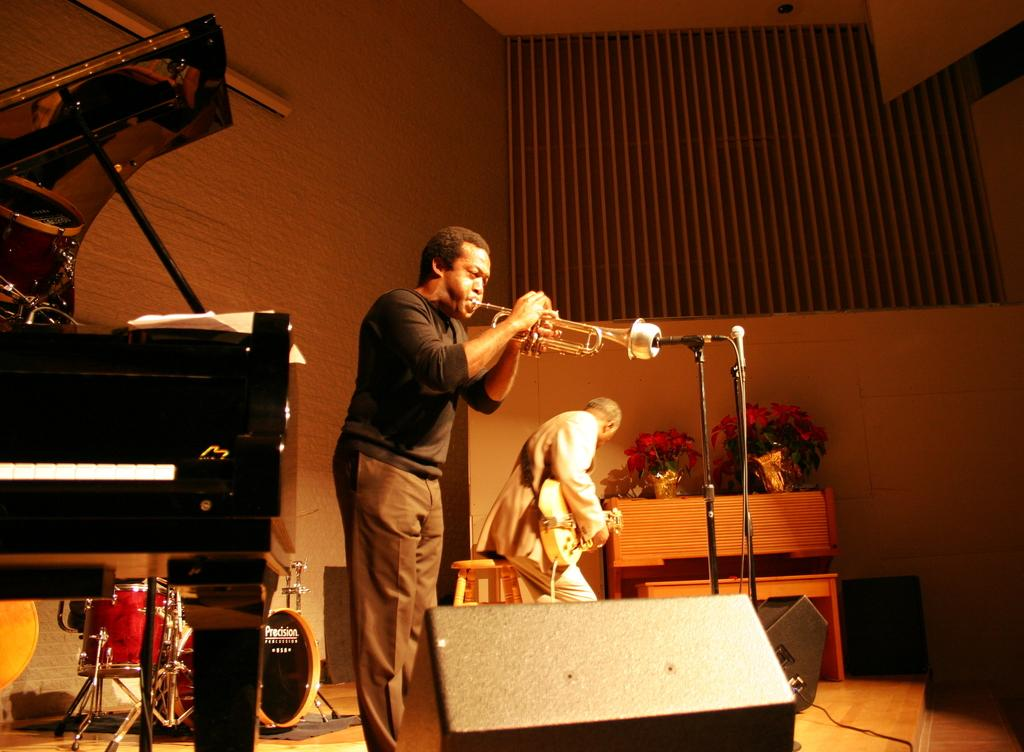What is the man in the image doing? The man is playing a saxophone. Can you describe the other person in the image? The second man is seated on a wooden block and holding a guitar. What musical instrument is in the left corner of the image? There is a piano in the left corner of the image. How many people are playing musical instruments in the image? Two people are playing musical instruments in the image. What type of food is the man eating while playing the saxophone? There is no food present in the image; the man is playing a saxophone. What type of clover can be seen growing near the piano? There is no clover present in the image. 